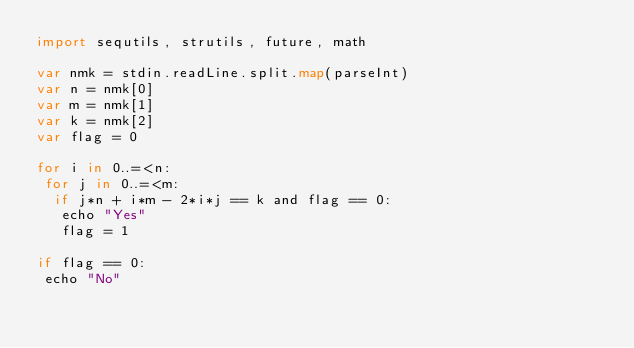Convert code to text. <code><loc_0><loc_0><loc_500><loc_500><_Nim_>import sequtils, strutils, future, math

var nmk = stdin.readLine.split.map(parseInt)
var n = nmk[0]
var m = nmk[1]
var k = nmk[2]
var flag = 0

for i in 0..=<n:
 for j in 0..=<m:
  if j*n + i*m - 2*i*j == k and flag == 0:
   echo "Yes"
   flag = 1

if flag == 0:
 echo "No"</code> 